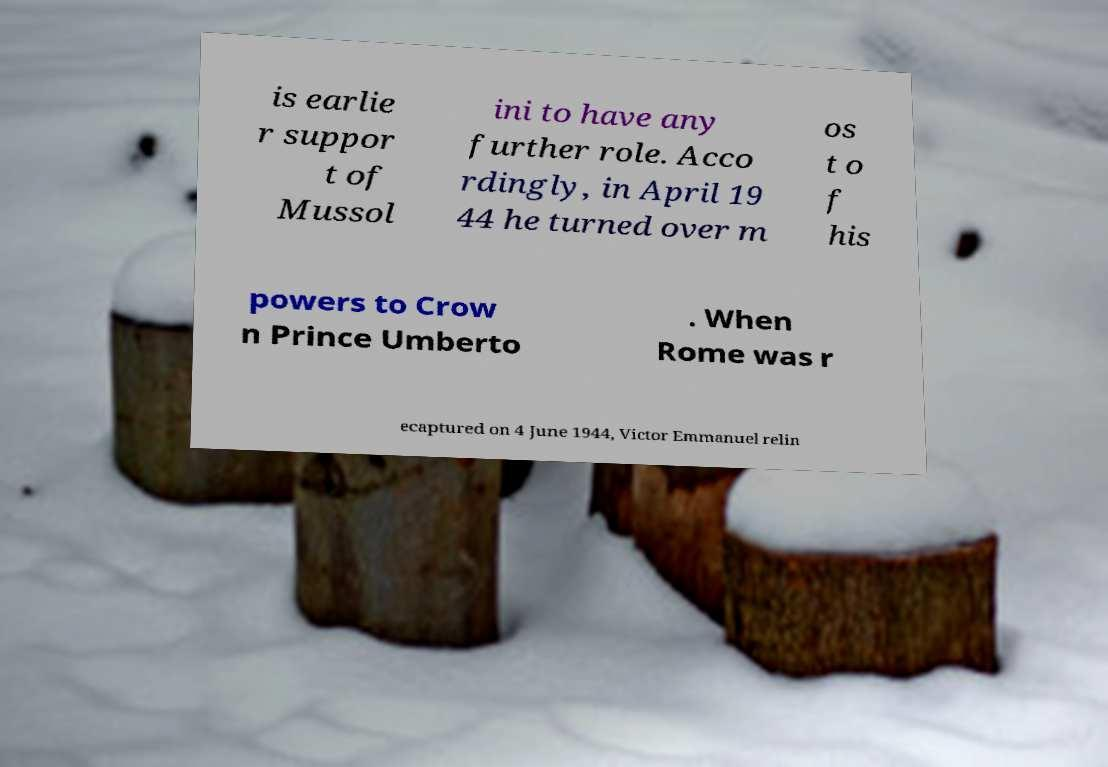For documentation purposes, I need the text within this image transcribed. Could you provide that? is earlie r suppor t of Mussol ini to have any further role. Acco rdingly, in April 19 44 he turned over m os t o f his powers to Crow n Prince Umberto . When Rome was r ecaptured on 4 June 1944, Victor Emmanuel relin 